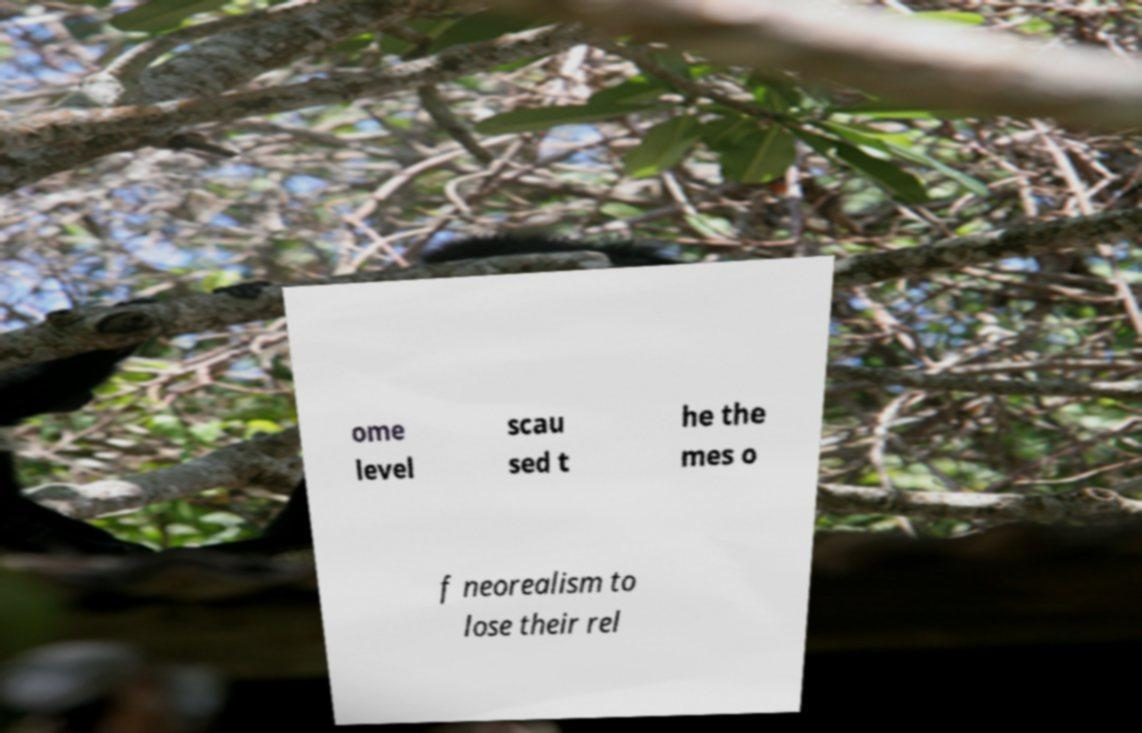What messages or text are displayed in this image? I need them in a readable, typed format. ome level scau sed t he the mes o f neorealism to lose their rel 